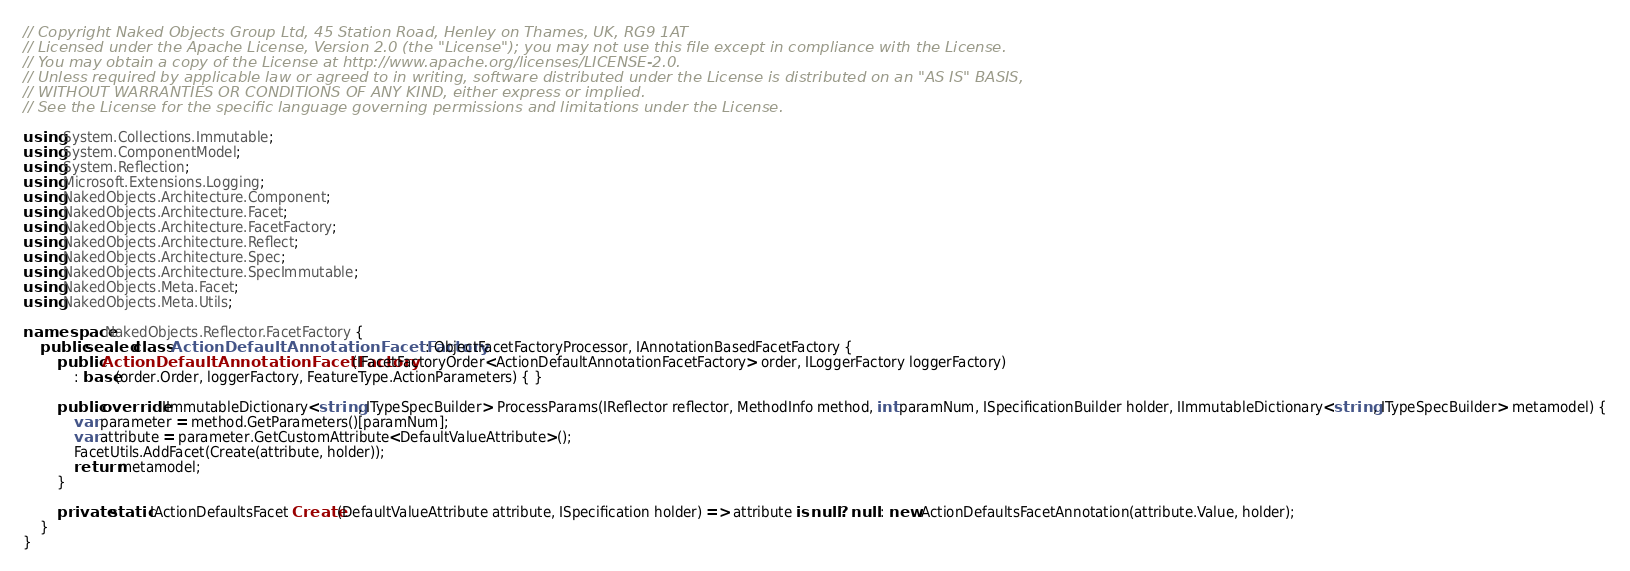Convert code to text. <code><loc_0><loc_0><loc_500><loc_500><_C#_>// Copyright Naked Objects Group Ltd, 45 Station Road, Henley on Thames, UK, RG9 1AT
// Licensed under the Apache License, Version 2.0 (the "License"); you may not use this file except in compliance with the License.
// You may obtain a copy of the License at http://www.apache.org/licenses/LICENSE-2.0.
// Unless required by applicable law or agreed to in writing, software distributed under the License is distributed on an "AS IS" BASIS,
// WITHOUT WARRANTIES OR CONDITIONS OF ANY KIND, either express or implied.
// See the License for the specific language governing permissions and limitations under the License.

using System.Collections.Immutable;
using System.ComponentModel;
using System.Reflection;
using Microsoft.Extensions.Logging;
using NakedObjects.Architecture.Component;
using NakedObjects.Architecture.Facet;
using NakedObjects.Architecture.FacetFactory;
using NakedObjects.Architecture.Reflect;
using NakedObjects.Architecture.Spec;
using NakedObjects.Architecture.SpecImmutable;
using NakedObjects.Meta.Facet;
using NakedObjects.Meta.Utils;

namespace NakedObjects.Reflector.FacetFactory {
    public sealed class ActionDefaultAnnotationFacetFactory : ObjectFacetFactoryProcessor, IAnnotationBasedFacetFactory {
        public ActionDefaultAnnotationFacetFactory(IFacetFactoryOrder<ActionDefaultAnnotationFacetFactory> order, ILoggerFactory loggerFactory)
            : base(order.Order, loggerFactory, FeatureType.ActionParameters) { }

        public override IImmutableDictionary<string, ITypeSpecBuilder> ProcessParams(IReflector reflector, MethodInfo method, int paramNum, ISpecificationBuilder holder, IImmutableDictionary<string, ITypeSpecBuilder> metamodel) {
            var parameter = method.GetParameters()[paramNum];
            var attribute = parameter.GetCustomAttribute<DefaultValueAttribute>();
            FacetUtils.AddFacet(Create(attribute, holder));
            return metamodel;
        }

        private static IActionDefaultsFacet Create(DefaultValueAttribute attribute, ISpecification holder) => attribute is null ? null : new ActionDefaultsFacetAnnotation(attribute.Value, holder);
    }
}</code> 